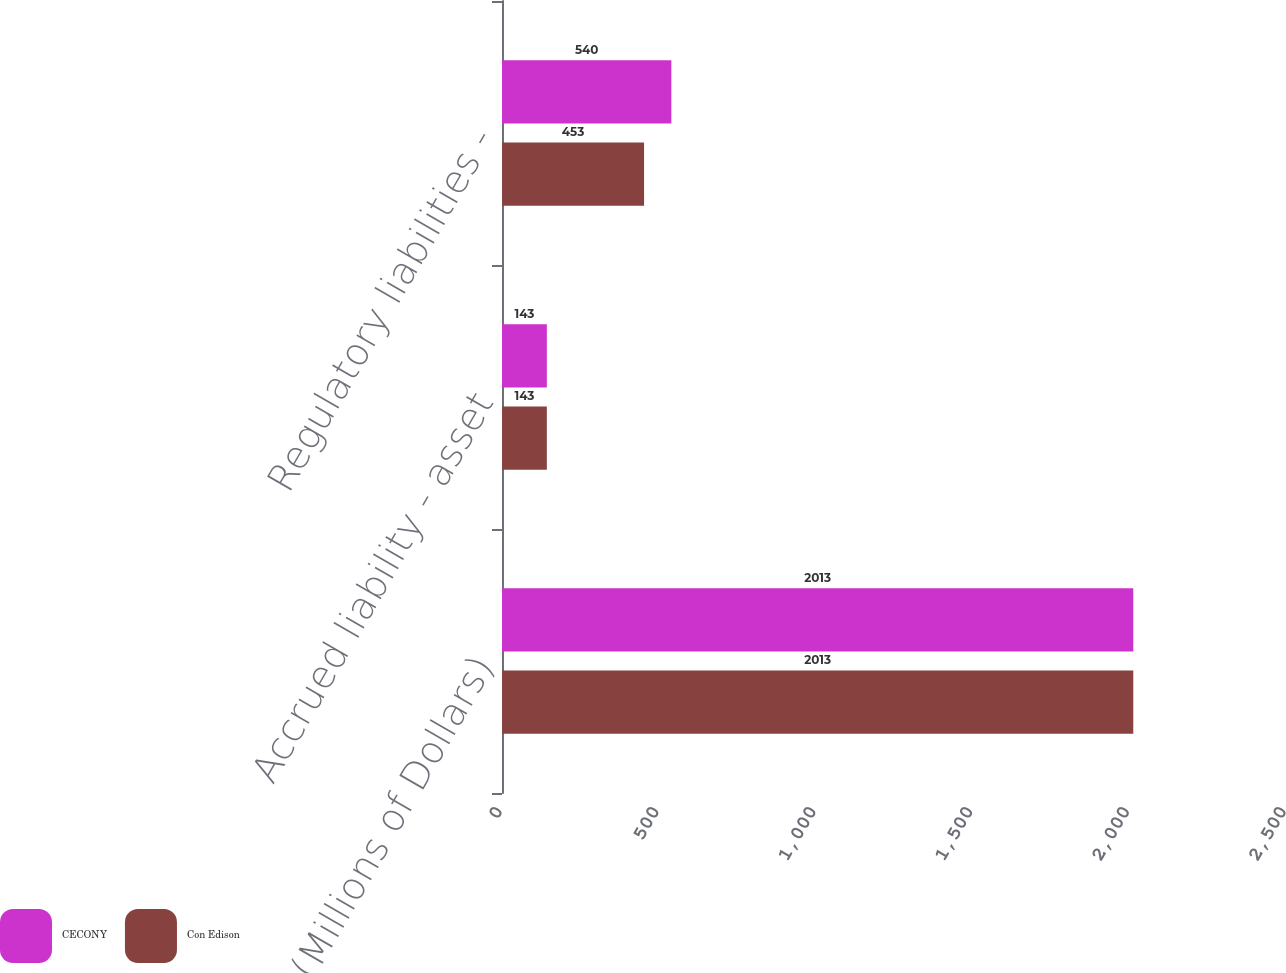Convert chart. <chart><loc_0><loc_0><loc_500><loc_500><stacked_bar_chart><ecel><fcel>(Millions of Dollars)<fcel>Accrued liability - asset<fcel>Regulatory liabilities -<nl><fcel>CECONY<fcel>2013<fcel>143<fcel>540<nl><fcel>Con Edison<fcel>2013<fcel>143<fcel>453<nl></chart> 